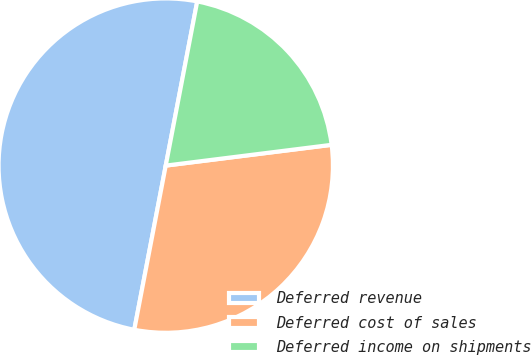Convert chart to OTSL. <chart><loc_0><loc_0><loc_500><loc_500><pie_chart><fcel>Deferred revenue<fcel>Deferred cost of sales<fcel>Deferred income on shipments<nl><fcel>50.0%<fcel>30.0%<fcel>20.0%<nl></chart> 